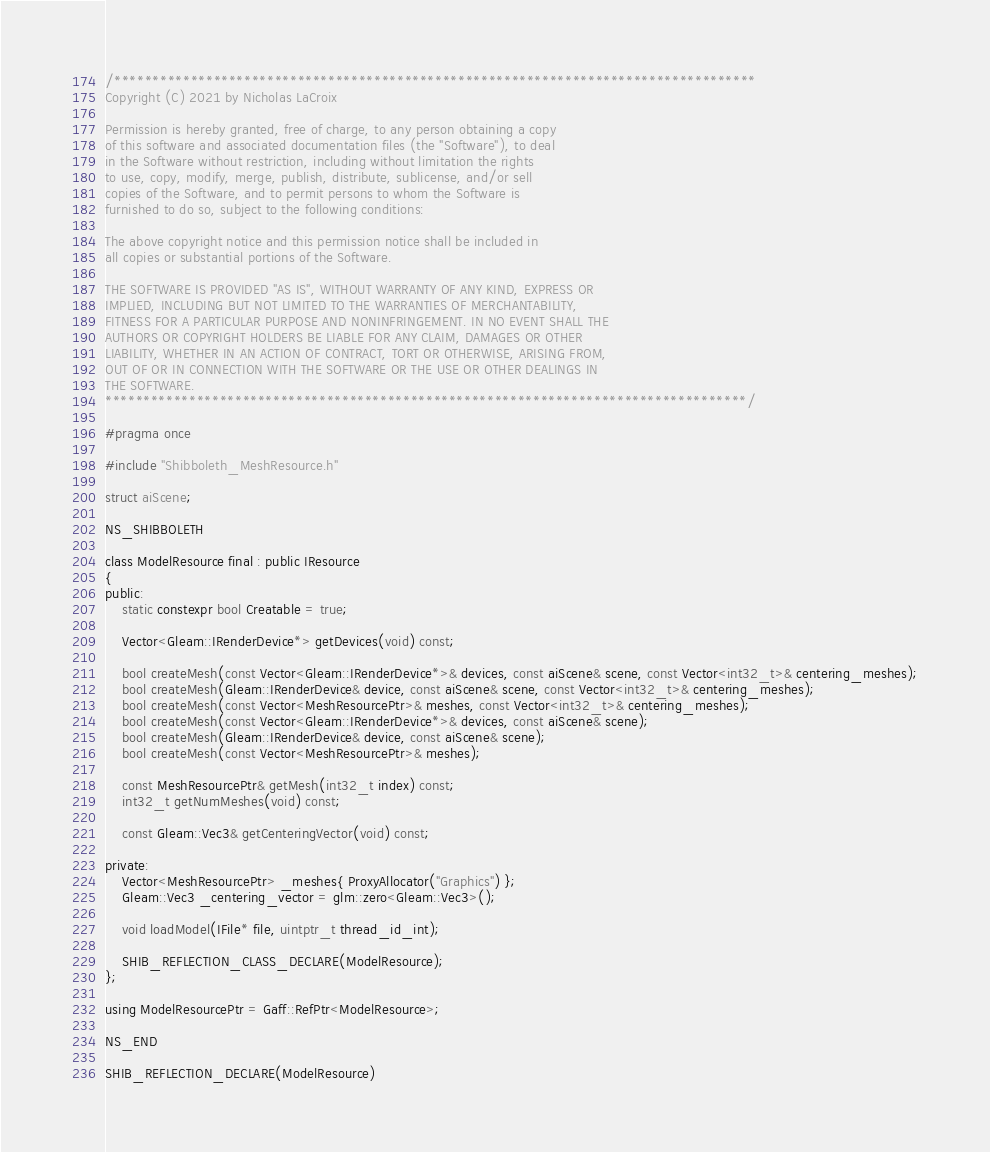Convert code to text. <code><loc_0><loc_0><loc_500><loc_500><_C_>/************************************************************************************
Copyright (C) 2021 by Nicholas LaCroix

Permission is hereby granted, free of charge, to any person obtaining a copy
of this software and associated documentation files (the "Software"), to deal
in the Software without restriction, including without limitation the rights
to use, copy, modify, merge, publish, distribute, sublicense, and/or sell
copies of the Software, and to permit persons to whom the Software is
furnished to do so, subject to the following conditions:

The above copyright notice and this permission notice shall be included in
all copies or substantial portions of the Software.

THE SOFTWARE IS PROVIDED "AS IS", WITHOUT WARRANTY OF ANY KIND, EXPRESS OR
IMPLIED, INCLUDING BUT NOT LIMITED TO THE WARRANTIES OF MERCHANTABILITY,
FITNESS FOR A PARTICULAR PURPOSE AND NONINFRINGEMENT. IN NO EVENT SHALL THE
AUTHORS OR COPYRIGHT HOLDERS BE LIABLE FOR ANY CLAIM, DAMAGES OR OTHER
LIABILITY, WHETHER IN AN ACTION OF CONTRACT, TORT OR OTHERWISE, ARISING FROM,
OUT OF OR IN CONNECTION WITH THE SOFTWARE OR THE USE OR OTHER DEALINGS IN
THE SOFTWARE.
************************************************************************************/

#pragma once

#include "Shibboleth_MeshResource.h"

struct aiScene;

NS_SHIBBOLETH

class ModelResource final : public IResource
{
public:
	static constexpr bool Creatable = true;

	Vector<Gleam::IRenderDevice*> getDevices(void) const;

	bool createMesh(const Vector<Gleam::IRenderDevice*>& devices, const aiScene& scene, const Vector<int32_t>& centering_meshes);
	bool createMesh(Gleam::IRenderDevice& device, const aiScene& scene, const Vector<int32_t>& centering_meshes);
	bool createMesh(const Vector<MeshResourcePtr>& meshes, const Vector<int32_t>& centering_meshes);
	bool createMesh(const Vector<Gleam::IRenderDevice*>& devices, const aiScene& scene);
	bool createMesh(Gleam::IRenderDevice& device, const aiScene& scene);
	bool createMesh(const Vector<MeshResourcePtr>& meshes);

	const MeshResourcePtr& getMesh(int32_t index) const;
	int32_t getNumMeshes(void) const;

	const Gleam::Vec3& getCenteringVector(void) const;

private:
	Vector<MeshResourcePtr> _meshes{ ProxyAllocator("Graphics") };
	Gleam::Vec3 _centering_vector = glm::zero<Gleam::Vec3>();

	void loadModel(IFile* file, uintptr_t thread_id_int);

	SHIB_REFLECTION_CLASS_DECLARE(ModelResource);
};

using ModelResourcePtr = Gaff::RefPtr<ModelResource>;

NS_END

SHIB_REFLECTION_DECLARE(ModelResource)
</code> 